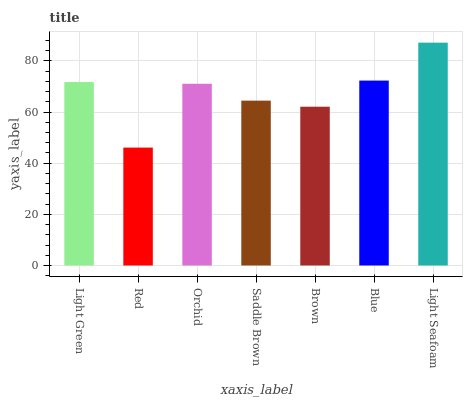Is Red the minimum?
Answer yes or no. Yes. Is Light Seafoam the maximum?
Answer yes or no. Yes. Is Orchid the minimum?
Answer yes or no. No. Is Orchid the maximum?
Answer yes or no. No. Is Orchid greater than Red?
Answer yes or no. Yes. Is Red less than Orchid?
Answer yes or no. Yes. Is Red greater than Orchid?
Answer yes or no. No. Is Orchid less than Red?
Answer yes or no. No. Is Orchid the high median?
Answer yes or no. Yes. Is Orchid the low median?
Answer yes or no. Yes. Is Light Green the high median?
Answer yes or no. No. Is Light Seafoam the low median?
Answer yes or no. No. 